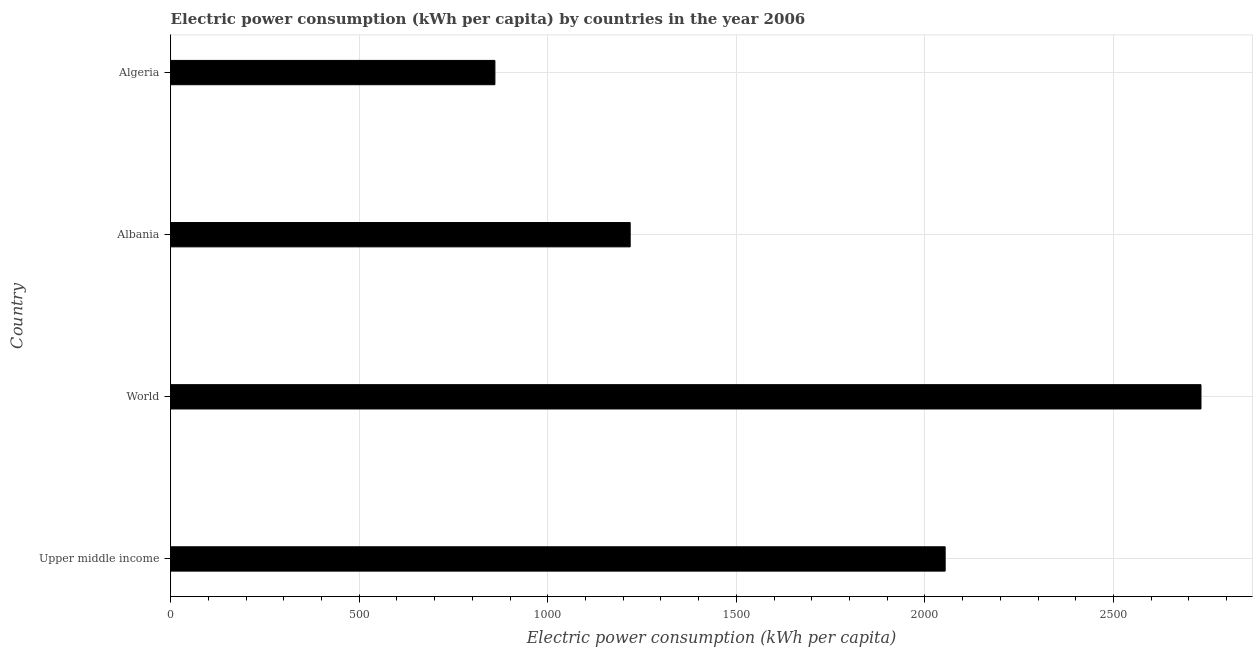What is the title of the graph?
Provide a succinct answer. Electric power consumption (kWh per capita) by countries in the year 2006. What is the label or title of the X-axis?
Give a very brief answer. Electric power consumption (kWh per capita). What is the label or title of the Y-axis?
Your answer should be very brief. Country. What is the electric power consumption in World?
Give a very brief answer. 2731.92. Across all countries, what is the maximum electric power consumption?
Offer a terse response. 2731.92. Across all countries, what is the minimum electric power consumption?
Your answer should be compact. 859.66. In which country was the electric power consumption minimum?
Offer a very short reply. Algeria. What is the sum of the electric power consumption?
Make the answer very short. 6863.51. What is the difference between the electric power consumption in Algeria and World?
Your answer should be compact. -1872.26. What is the average electric power consumption per country?
Offer a terse response. 1715.88. What is the median electric power consumption?
Offer a very short reply. 1635.96. What is the ratio of the electric power consumption in Algeria to that in World?
Offer a very short reply. 0.32. What is the difference between the highest and the second highest electric power consumption?
Provide a short and direct response. 678.35. What is the difference between the highest and the lowest electric power consumption?
Provide a succinct answer. 1872.26. In how many countries, is the electric power consumption greater than the average electric power consumption taken over all countries?
Your answer should be compact. 2. How many countries are there in the graph?
Provide a succinct answer. 4. What is the Electric power consumption (kWh per capita) in Upper middle income?
Ensure brevity in your answer.  2053.57. What is the Electric power consumption (kWh per capita) in World?
Your response must be concise. 2731.92. What is the Electric power consumption (kWh per capita) of Albania?
Offer a terse response. 1218.36. What is the Electric power consumption (kWh per capita) of Algeria?
Provide a succinct answer. 859.66. What is the difference between the Electric power consumption (kWh per capita) in Upper middle income and World?
Your response must be concise. -678.35. What is the difference between the Electric power consumption (kWh per capita) in Upper middle income and Albania?
Ensure brevity in your answer.  835.21. What is the difference between the Electric power consumption (kWh per capita) in Upper middle income and Algeria?
Your answer should be very brief. 1193.91. What is the difference between the Electric power consumption (kWh per capita) in World and Albania?
Keep it short and to the point. 1513.56. What is the difference between the Electric power consumption (kWh per capita) in World and Algeria?
Provide a short and direct response. 1872.26. What is the difference between the Electric power consumption (kWh per capita) in Albania and Algeria?
Keep it short and to the point. 358.7. What is the ratio of the Electric power consumption (kWh per capita) in Upper middle income to that in World?
Provide a succinct answer. 0.75. What is the ratio of the Electric power consumption (kWh per capita) in Upper middle income to that in Albania?
Provide a succinct answer. 1.69. What is the ratio of the Electric power consumption (kWh per capita) in Upper middle income to that in Algeria?
Offer a terse response. 2.39. What is the ratio of the Electric power consumption (kWh per capita) in World to that in Albania?
Keep it short and to the point. 2.24. What is the ratio of the Electric power consumption (kWh per capita) in World to that in Algeria?
Your answer should be compact. 3.18. What is the ratio of the Electric power consumption (kWh per capita) in Albania to that in Algeria?
Your answer should be compact. 1.42. 